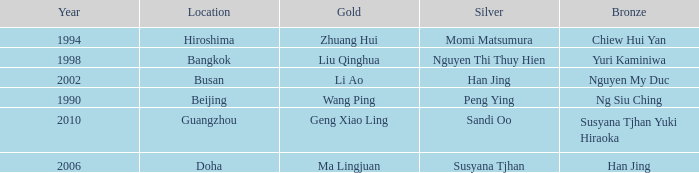What Silver has the Location of Guangzhou? Sandi Oo. 